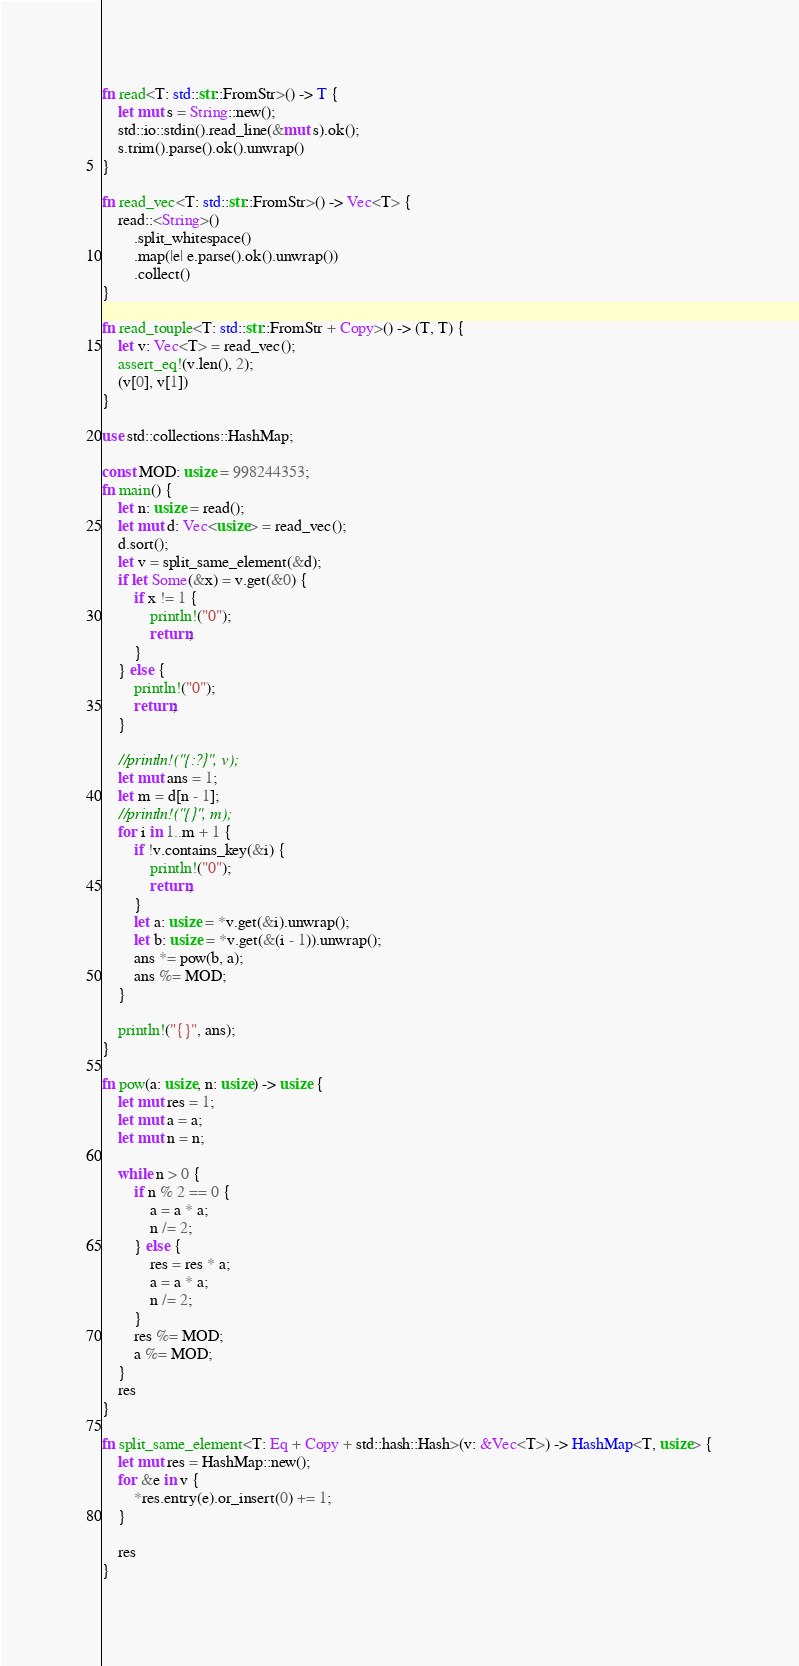Convert code to text. <code><loc_0><loc_0><loc_500><loc_500><_Rust_>fn read<T: std::str::FromStr>() -> T {
    let mut s = String::new();
    std::io::stdin().read_line(&mut s).ok();
    s.trim().parse().ok().unwrap()
}

fn read_vec<T: std::str::FromStr>() -> Vec<T> {
    read::<String>()
        .split_whitespace()
        .map(|e| e.parse().ok().unwrap())
        .collect()
}

fn read_touple<T: std::str::FromStr + Copy>() -> (T, T) {
    let v: Vec<T> = read_vec();
    assert_eq!(v.len(), 2);
    (v[0], v[1])
}

use std::collections::HashMap;

const MOD: usize = 998244353;
fn main() {
    let n: usize = read();
    let mut d: Vec<usize> = read_vec();
    d.sort();
    let v = split_same_element(&d);
    if let Some(&x) = v.get(&0) {
        if x != 1 {
            println!("0");
            return;
        }
    } else {
        println!("0");
        return;
    }

    //println!("{:?}", v);
    let mut ans = 1;
    let m = d[n - 1];
    //println!("{}", m);
    for i in 1..m + 1 {
        if !v.contains_key(&i) {
            println!("0");
            return;
        }
        let a: usize = *v.get(&i).unwrap();
        let b: usize = *v.get(&(i - 1)).unwrap();
        ans *= pow(b, a);
        ans %= MOD;
    }

    println!("{}", ans);
}

fn pow(a: usize, n: usize) -> usize {
    let mut res = 1;
    let mut a = a;
    let mut n = n;

    while n > 0 {
        if n % 2 == 0 {
            a = a * a;
            n /= 2;
        } else {
            res = res * a;
            a = a * a;
            n /= 2;
        }
        res %= MOD;
        a %= MOD;
    }
    res
}

fn split_same_element<T: Eq + Copy + std::hash::Hash>(v: &Vec<T>) -> HashMap<T, usize> {
    let mut res = HashMap::new();
    for &e in v {
        *res.entry(e).or_insert(0) += 1;
    }

    res
}
</code> 